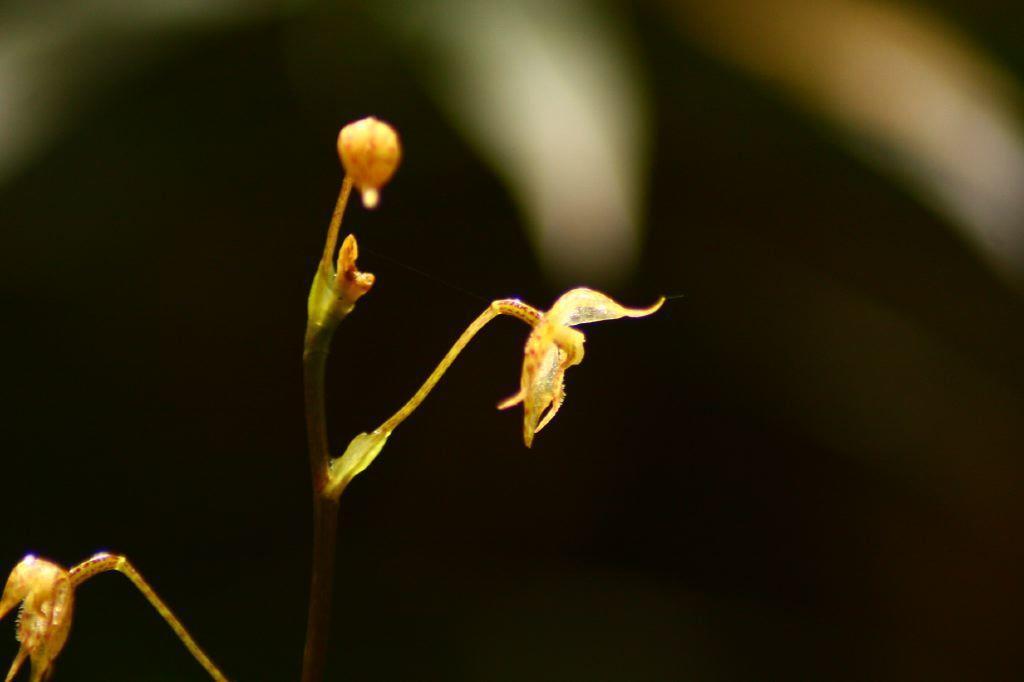Describe this image in one or two sentences. In this image we can see a plant, here is the flower, at back ground it is black. 